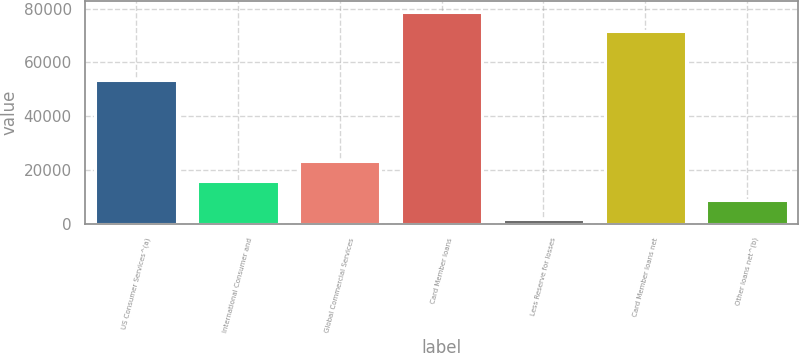Convert chart. <chart><loc_0><loc_0><loc_500><loc_500><bar_chart><fcel>US Consumer Services^(a)<fcel>International Consumer and<fcel>Global Commercial Services<fcel>Card Member loans<fcel>Less Reserve for losses<fcel>Card Member loans net<fcel>Other loans net^(b)<nl><fcel>53668<fcel>16044.6<fcel>23213.9<fcel>78862.3<fcel>1706<fcel>71693<fcel>8875.3<nl></chart> 